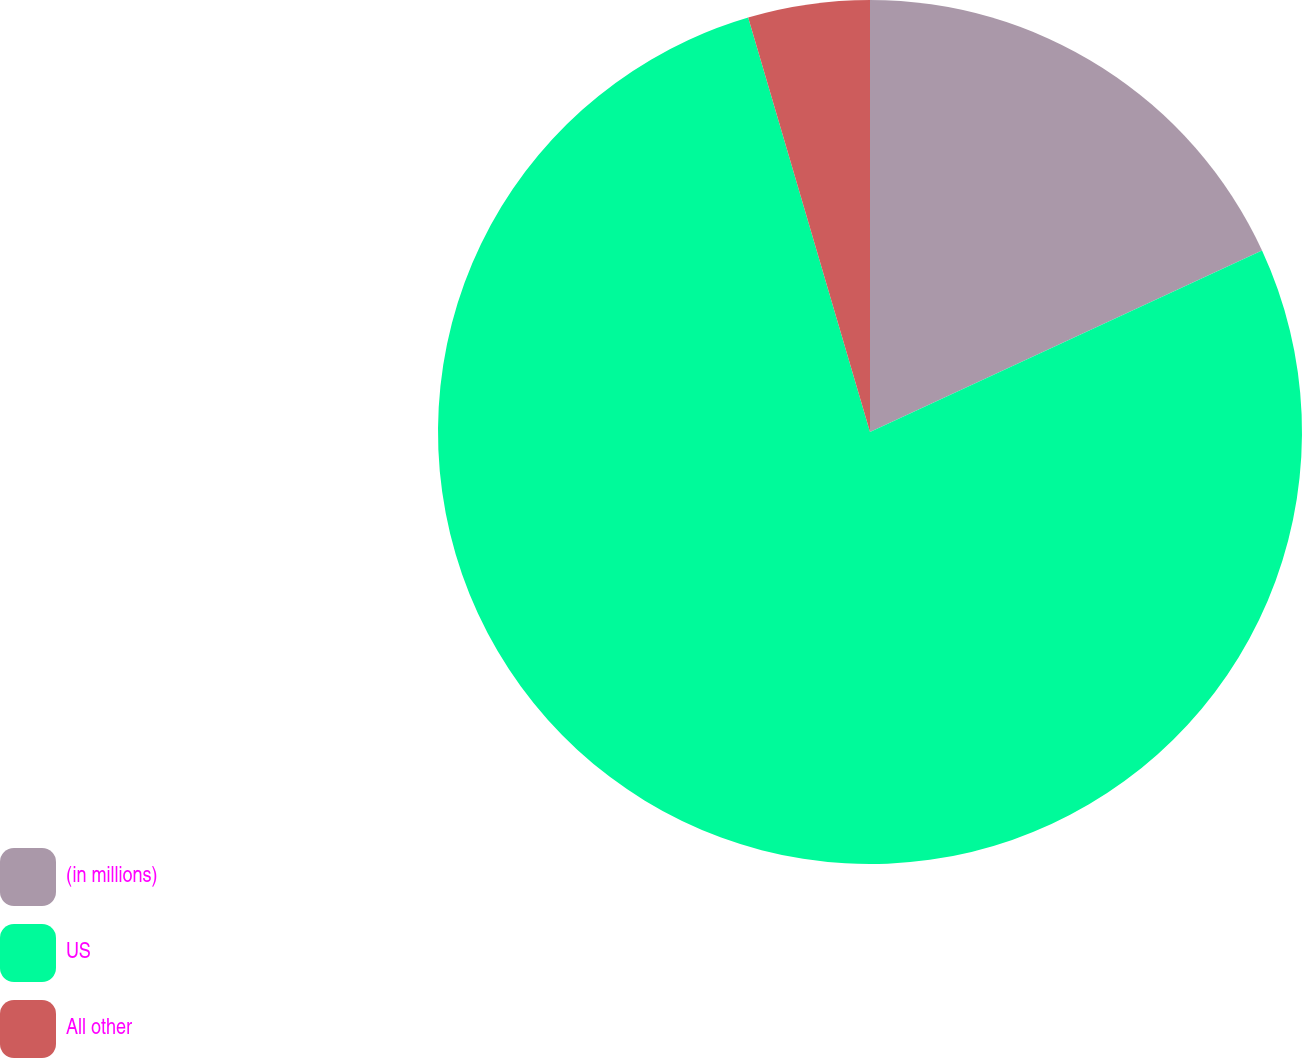Convert chart. <chart><loc_0><loc_0><loc_500><loc_500><pie_chart><fcel>(in millions)<fcel>US<fcel>All other<nl><fcel>18.1%<fcel>77.35%<fcel>4.55%<nl></chart> 